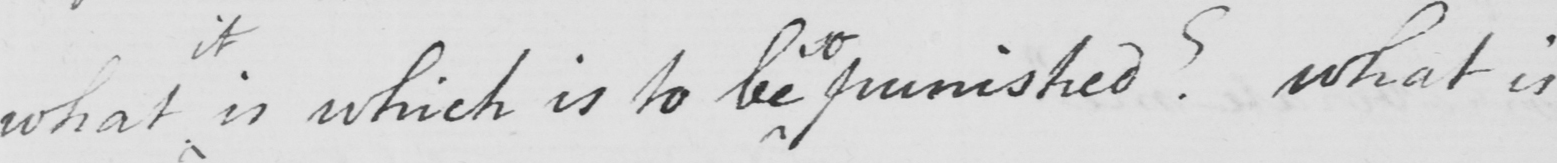Please transcribe the handwritten text in this image. what is which is to be so punished ?  What is 